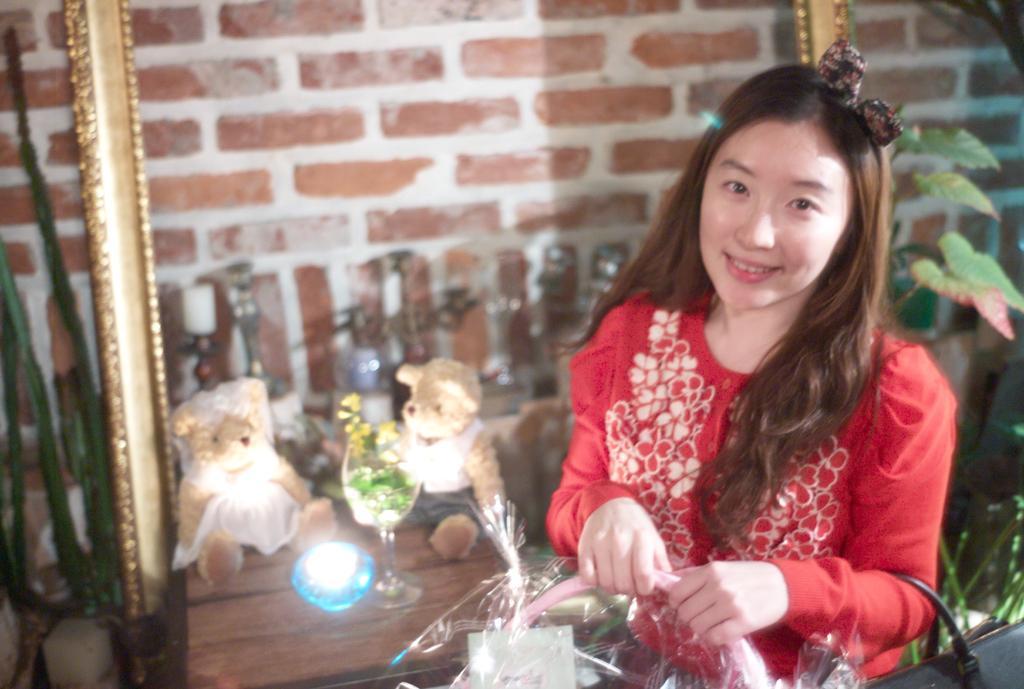Describe this image in one or two sentences. In this image, we can see a person wearing a bag and holding an object with her hands. There is a table at the bottom of the image contains teddy bears, glass and light. There are leaves on the right side of the image. In the background, we can see a wall. 